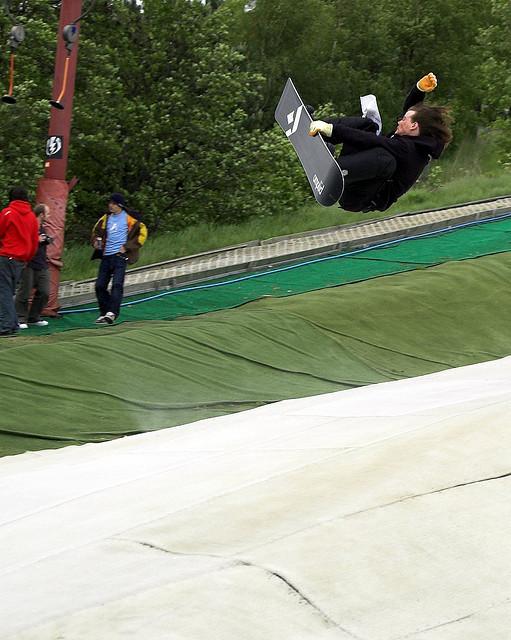What color jacket is the person on the far left wearing?
Be succinct. Red. What color is his hat?
Short answer required. Black. How high is this athlete jumping?
Give a very brief answer. Very high. Why isn't there any snow?
Keep it brief. Summer. What color is the snowboard?
Short answer required. Black. 